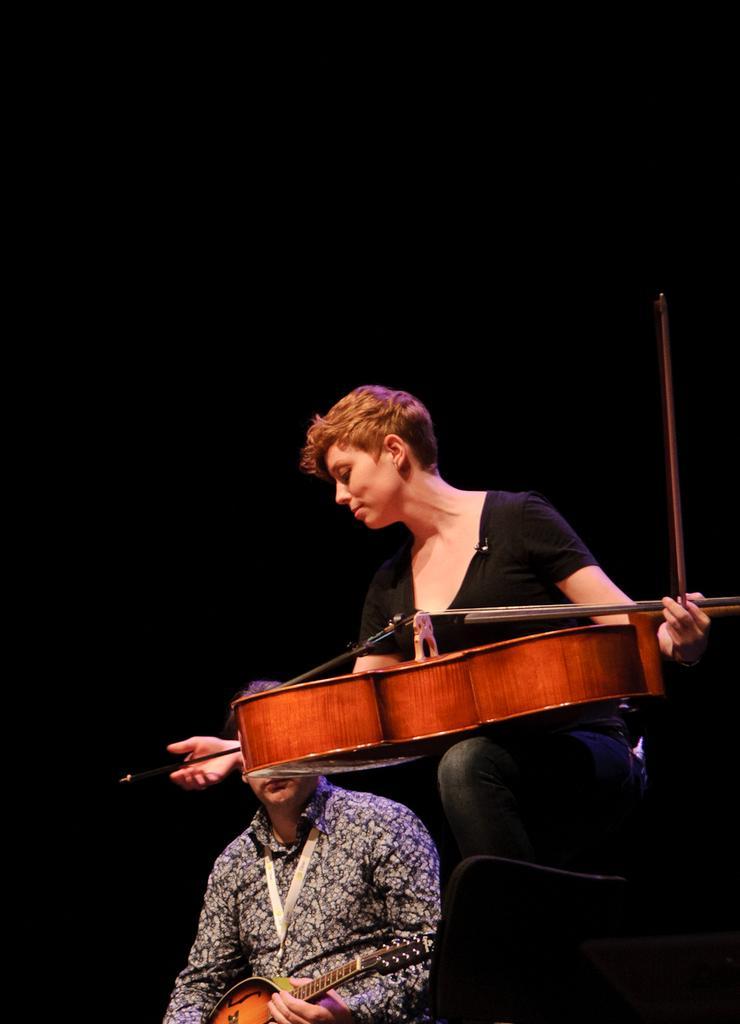In one or two sentences, can you explain what this image depicts? The background is very dark. here we can see one person holding a guitar in her hands. near to this person we can see another person holding an musical instrument. 